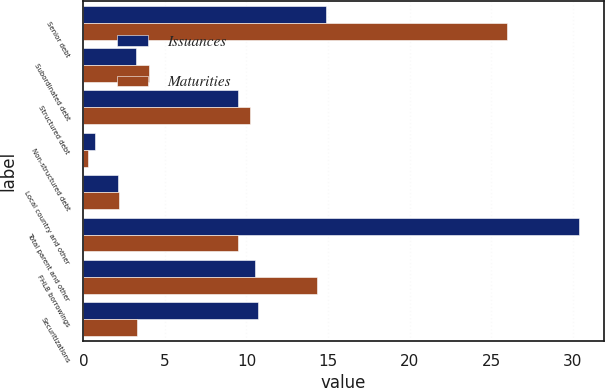Convert chart to OTSL. <chart><loc_0><loc_0><loc_500><loc_500><stacked_bar_chart><ecel><fcel>Senior debt<fcel>Subordinated debt<fcel>Structured debt<fcel>Non-structured debt<fcel>Local country and other<fcel>Total parent and other<fcel>FHLB borrowings<fcel>Securitizations<nl><fcel>Issuances<fcel>14.9<fcel>3.2<fcel>9.5<fcel>0.7<fcel>2.1<fcel>30.4<fcel>10.5<fcel>10.7<nl><fcel>Maturities<fcel>26<fcel>4<fcel>10.2<fcel>0.3<fcel>2.2<fcel>9.5<fcel>14.3<fcel>3.3<nl></chart> 